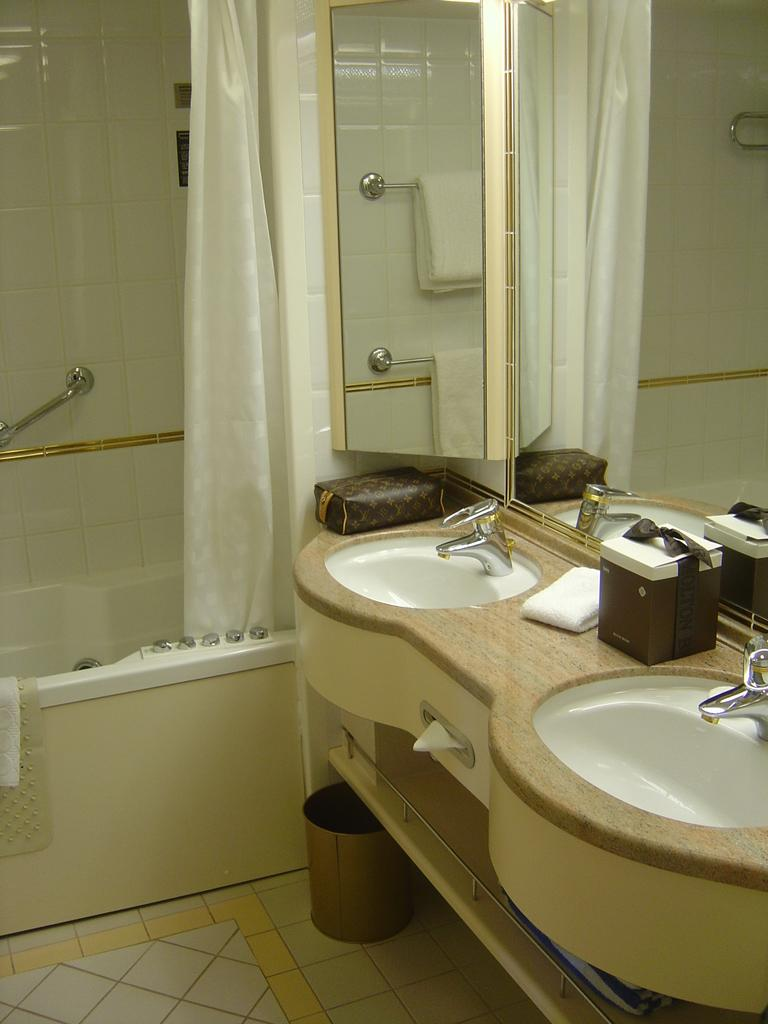What type of fixtures can be seen in the image? There are sinks and taps in the image. What can be used for wiping or drying hands in the image? There are tissue papers in the image. What objects are placed on the sink? There are objects on the sink, but the specific items are not mentioned in the facts. What type of window treatment is present in the image? There is a curtain in the image. What can be used for personal grooming in the image? There are mirrors in the image. What is a large container for holding water in the image? There is a bath tub in the image. What is a device for spraying water in the image? There is a shower in the image. What is a container for waste on the floor in the image? There is a dustbin on the floor in the image. What type of steel is used to construct the chicken in the image? There is no chicken present in the image, and therefore no steel construction can be observed. What type of sail can be seen in the image? There is no sail present in the image. 